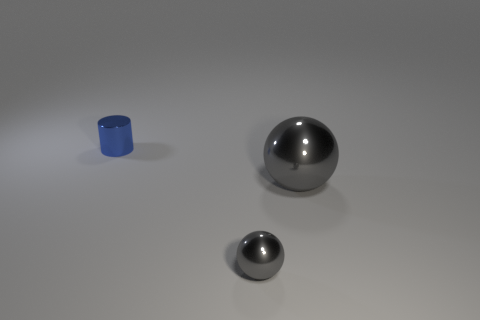Add 2 small gray things. How many objects exist? 5 Subtract all cylinders. How many objects are left? 2 Subtract 1 gray balls. How many objects are left? 2 Subtract all shiny balls. Subtract all tiny red metal cubes. How many objects are left? 1 Add 3 large shiny objects. How many large shiny objects are left? 4 Add 1 large yellow shiny cubes. How many large yellow shiny cubes exist? 1 